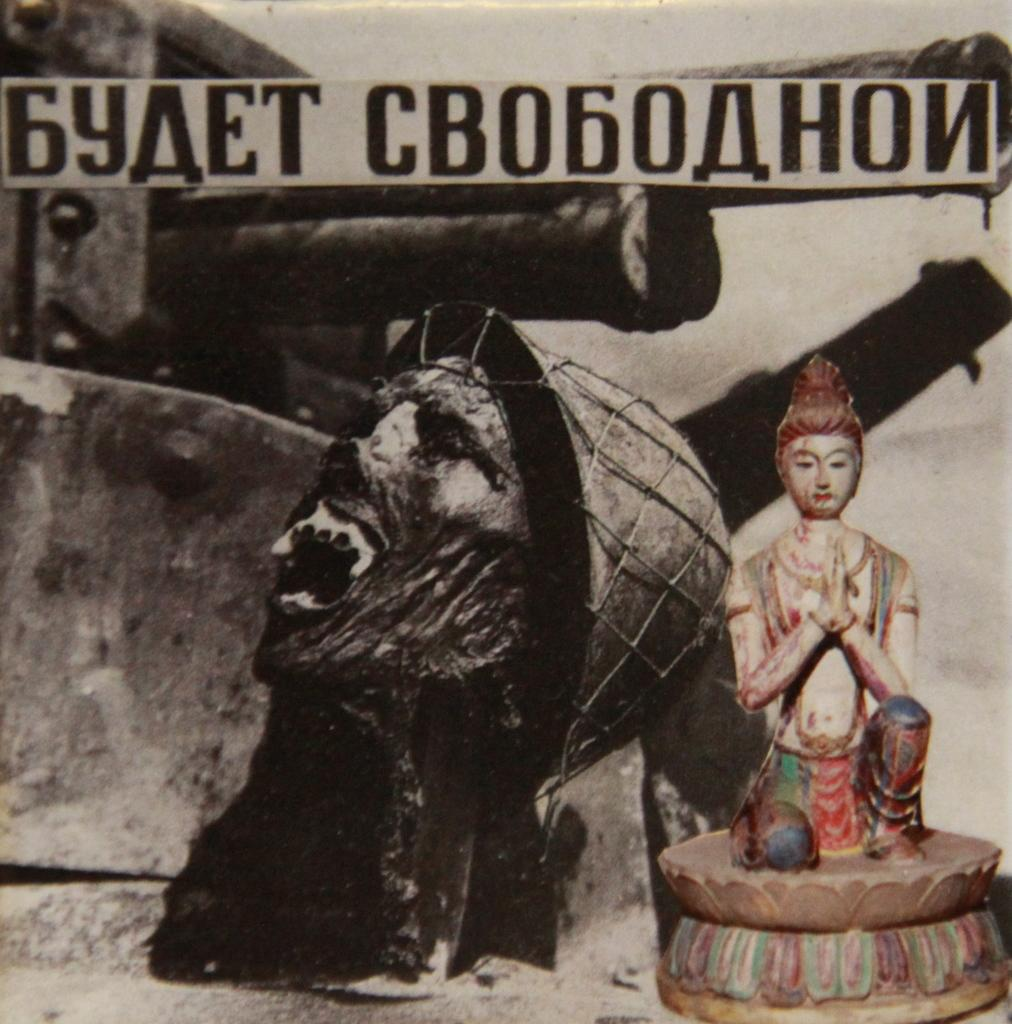What is present in the image that contains both images and text? There is a poster in the image that contains images and text. How many geese are swimming in the boat depicted on the poster? There is no boat or geese depicted on the poster; it only contains images and text. 